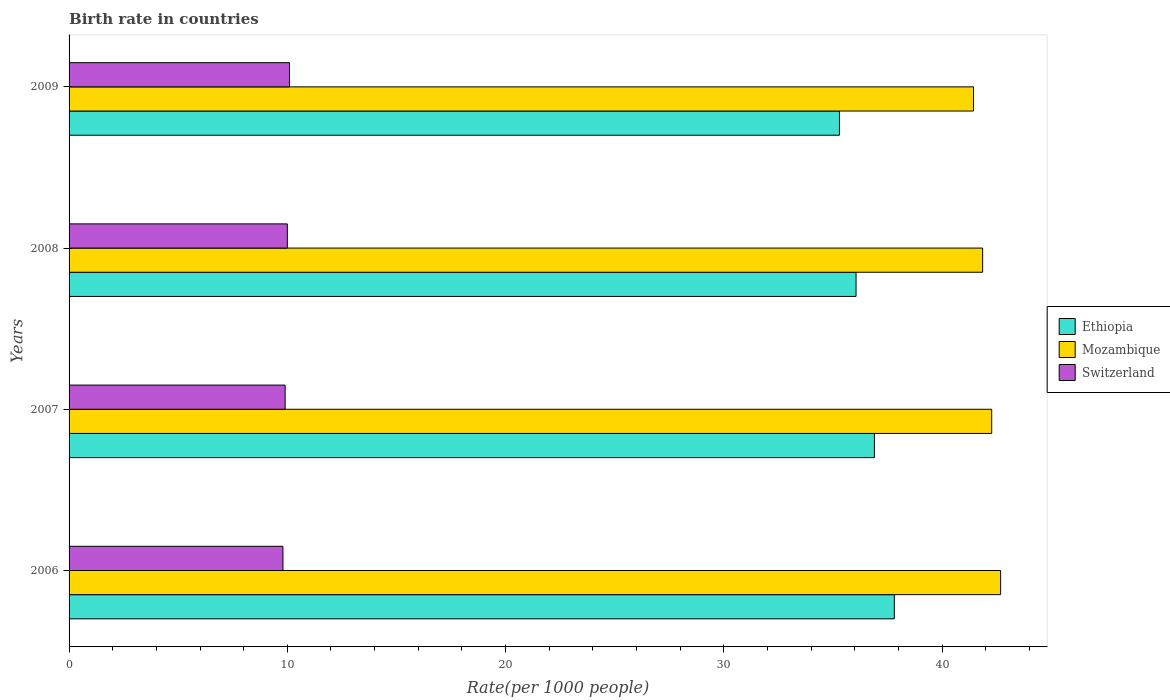How many groups of bars are there?
Your answer should be very brief. 4. Are the number of bars on each tick of the Y-axis equal?
Make the answer very short. Yes. How many bars are there on the 1st tick from the bottom?
Ensure brevity in your answer.  3. What is the birth rate in Ethiopia in 2007?
Offer a very short reply. 36.9. Across all years, what is the maximum birth rate in Mozambique?
Your answer should be compact. 42.69. Across all years, what is the minimum birth rate in Mozambique?
Offer a terse response. 41.44. What is the total birth rate in Switzerland in the graph?
Ensure brevity in your answer.  39.8. What is the difference between the birth rate in Ethiopia in 2008 and that in 2009?
Your answer should be compact. 0.76. What is the difference between the birth rate in Switzerland in 2006 and the birth rate in Ethiopia in 2008?
Give a very brief answer. -26.26. What is the average birth rate in Switzerland per year?
Make the answer very short. 9.95. In the year 2009, what is the difference between the birth rate in Ethiopia and birth rate in Mozambique?
Give a very brief answer. -6.14. What is the ratio of the birth rate in Ethiopia in 2006 to that in 2009?
Provide a short and direct response. 1.07. What is the difference between the highest and the second highest birth rate in Mozambique?
Provide a short and direct response. 0.41. What is the difference between the highest and the lowest birth rate in Ethiopia?
Make the answer very short. 2.51. In how many years, is the birth rate in Mozambique greater than the average birth rate in Mozambique taken over all years?
Ensure brevity in your answer.  2. Is the sum of the birth rate in Switzerland in 2007 and 2009 greater than the maximum birth rate in Mozambique across all years?
Make the answer very short. No. What does the 1st bar from the top in 2008 represents?
Keep it short and to the point. Switzerland. What does the 3rd bar from the bottom in 2006 represents?
Keep it short and to the point. Switzerland. Are the values on the major ticks of X-axis written in scientific E-notation?
Make the answer very short. No. Does the graph contain any zero values?
Give a very brief answer. No. Does the graph contain grids?
Your response must be concise. No. Where does the legend appear in the graph?
Provide a succinct answer. Center right. What is the title of the graph?
Keep it short and to the point. Birth rate in countries. Does "Tonga" appear as one of the legend labels in the graph?
Ensure brevity in your answer.  No. What is the label or title of the X-axis?
Your answer should be compact. Rate(per 1000 people). What is the label or title of the Y-axis?
Your answer should be compact. Years. What is the Rate(per 1000 people) of Ethiopia in 2006?
Keep it short and to the point. 37.81. What is the Rate(per 1000 people) in Mozambique in 2006?
Your answer should be compact. 42.69. What is the Rate(per 1000 people) in Switzerland in 2006?
Offer a very short reply. 9.8. What is the Rate(per 1000 people) of Ethiopia in 2007?
Provide a short and direct response. 36.9. What is the Rate(per 1000 people) of Mozambique in 2007?
Your response must be concise. 42.28. What is the Rate(per 1000 people) of Ethiopia in 2008?
Provide a short and direct response. 36.06. What is the Rate(per 1000 people) in Mozambique in 2008?
Make the answer very short. 41.86. What is the Rate(per 1000 people) of Ethiopia in 2009?
Your answer should be compact. 35.3. What is the Rate(per 1000 people) of Mozambique in 2009?
Offer a very short reply. 41.44. Across all years, what is the maximum Rate(per 1000 people) in Ethiopia?
Your response must be concise. 37.81. Across all years, what is the maximum Rate(per 1000 people) in Mozambique?
Offer a very short reply. 42.69. Across all years, what is the maximum Rate(per 1000 people) of Switzerland?
Keep it short and to the point. 10.1. Across all years, what is the minimum Rate(per 1000 people) of Ethiopia?
Give a very brief answer. 35.3. Across all years, what is the minimum Rate(per 1000 people) of Mozambique?
Ensure brevity in your answer.  41.44. Across all years, what is the minimum Rate(per 1000 people) in Switzerland?
Provide a succinct answer. 9.8. What is the total Rate(per 1000 people) of Ethiopia in the graph?
Provide a short and direct response. 146.08. What is the total Rate(per 1000 people) of Mozambique in the graph?
Offer a very short reply. 168.27. What is the total Rate(per 1000 people) of Switzerland in the graph?
Provide a short and direct response. 39.8. What is the difference between the Rate(per 1000 people) of Ethiopia in 2006 and that in 2007?
Give a very brief answer. 0.91. What is the difference between the Rate(per 1000 people) of Mozambique in 2006 and that in 2007?
Make the answer very short. 0.41. What is the difference between the Rate(per 1000 people) of Switzerland in 2006 and that in 2007?
Keep it short and to the point. -0.1. What is the difference between the Rate(per 1000 people) of Ethiopia in 2006 and that in 2008?
Keep it short and to the point. 1.75. What is the difference between the Rate(per 1000 people) of Mozambique in 2006 and that in 2008?
Offer a very short reply. 0.82. What is the difference between the Rate(per 1000 people) of Ethiopia in 2006 and that in 2009?
Your answer should be very brief. 2.51. What is the difference between the Rate(per 1000 people) of Mozambique in 2006 and that in 2009?
Your answer should be compact. 1.24. What is the difference between the Rate(per 1000 people) of Switzerland in 2006 and that in 2009?
Your answer should be compact. -0.3. What is the difference between the Rate(per 1000 people) of Ethiopia in 2007 and that in 2008?
Give a very brief answer. 0.84. What is the difference between the Rate(per 1000 people) in Mozambique in 2007 and that in 2008?
Make the answer very short. 0.41. What is the difference between the Rate(per 1000 people) of Ethiopia in 2007 and that in 2009?
Give a very brief answer. 1.6. What is the difference between the Rate(per 1000 people) in Mozambique in 2007 and that in 2009?
Give a very brief answer. 0.83. What is the difference between the Rate(per 1000 people) in Ethiopia in 2008 and that in 2009?
Your answer should be compact. 0.76. What is the difference between the Rate(per 1000 people) of Mozambique in 2008 and that in 2009?
Your answer should be compact. 0.42. What is the difference between the Rate(per 1000 people) of Switzerland in 2008 and that in 2009?
Offer a very short reply. -0.1. What is the difference between the Rate(per 1000 people) of Ethiopia in 2006 and the Rate(per 1000 people) of Mozambique in 2007?
Your answer should be compact. -4.46. What is the difference between the Rate(per 1000 people) of Ethiopia in 2006 and the Rate(per 1000 people) of Switzerland in 2007?
Keep it short and to the point. 27.91. What is the difference between the Rate(per 1000 people) of Mozambique in 2006 and the Rate(per 1000 people) of Switzerland in 2007?
Provide a short and direct response. 32.78. What is the difference between the Rate(per 1000 people) of Ethiopia in 2006 and the Rate(per 1000 people) of Mozambique in 2008?
Provide a short and direct response. -4.05. What is the difference between the Rate(per 1000 people) in Ethiopia in 2006 and the Rate(per 1000 people) in Switzerland in 2008?
Offer a terse response. 27.82. What is the difference between the Rate(per 1000 people) of Mozambique in 2006 and the Rate(per 1000 people) of Switzerland in 2008?
Provide a short and direct response. 32.69. What is the difference between the Rate(per 1000 people) in Ethiopia in 2006 and the Rate(per 1000 people) in Mozambique in 2009?
Provide a succinct answer. -3.63. What is the difference between the Rate(per 1000 people) of Ethiopia in 2006 and the Rate(per 1000 people) of Switzerland in 2009?
Your answer should be very brief. 27.71. What is the difference between the Rate(per 1000 people) of Mozambique in 2006 and the Rate(per 1000 people) of Switzerland in 2009?
Keep it short and to the point. 32.59. What is the difference between the Rate(per 1000 people) of Ethiopia in 2007 and the Rate(per 1000 people) of Mozambique in 2008?
Your answer should be compact. -4.96. What is the difference between the Rate(per 1000 people) of Ethiopia in 2007 and the Rate(per 1000 people) of Switzerland in 2008?
Give a very brief answer. 26.9. What is the difference between the Rate(per 1000 people) in Mozambique in 2007 and the Rate(per 1000 people) in Switzerland in 2008?
Provide a succinct answer. 32.28. What is the difference between the Rate(per 1000 people) in Ethiopia in 2007 and the Rate(per 1000 people) in Mozambique in 2009?
Your response must be concise. -4.54. What is the difference between the Rate(per 1000 people) of Ethiopia in 2007 and the Rate(per 1000 people) of Switzerland in 2009?
Give a very brief answer. 26.8. What is the difference between the Rate(per 1000 people) in Mozambique in 2007 and the Rate(per 1000 people) in Switzerland in 2009?
Give a very brief answer. 32.18. What is the difference between the Rate(per 1000 people) of Ethiopia in 2008 and the Rate(per 1000 people) of Mozambique in 2009?
Your answer should be very brief. -5.38. What is the difference between the Rate(per 1000 people) of Ethiopia in 2008 and the Rate(per 1000 people) of Switzerland in 2009?
Offer a terse response. 25.96. What is the difference between the Rate(per 1000 people) in Mozambique in 2008 and the Rate(per 1000 people) in Switzerland in 2009?
Provide a short and direct response. 31.76. What is the average Rate(per 1000 people) of Ethiopia per year?
Offer a very short reply. 36.52. What is the average Rate(per 1000 people) of Mozambique per year?
Your answer should be very brief. 42.07. What is the average Rate(per 1000 people) of Switzerland per year?
Your response must be concise. 9.95. In the year 2006, what is the difference between the Rate(per 1000 people) in Ethiopia and Rate(per 1000 people) in Mozambique?
Your answer should be very brief. -4.87. In the year 2006, what is the difference between the Rate(per 1000 people) in Ethiopia and Rate(per 1000 people) in Switzerland?
Provide a short and direct response. 28.02. In the year 2006, what is the difference between the Rate(per 1000 people) of Mozambique and Rate(per 1000 people) of Switzerland?
Offer a terse response. 32.88. In the year 2007, what is the difference between the Rate(per 1000 people) of Ethiopia and Rate(per 1000 people) of Mozambique?
Make the answer very short. -5.37. In the year 2007, what is the difference between the Rate(per 1000 people) of Ethiopia and Rate(per 1000 people) of Switzerland?
Keep it short and to the point. 27. In the year 2007, what is the difference between the Rate(per 1000 people) of Mozambique and Rate(per 1000 people) of Switzerland?
Give a very brief answer. 32.38. In the year 2008, what is the difference between the Rate(per 1000 people) of Ethiopia and Rate(per 1000 people) of Mozambique?
Your answer should be very brief. -5.8. In the year 2008, what is the difference between the Rate(per 1000 people) in Ethiopia and Rate(per 1000 people) in Switzerland?
Offer a terse response. 26.06. In the year 2008, what is the difference between the Rate(per 1000 people) in Mozambique and Rate(per 1000 people) in Switzerland?
Offer a very short reply. 31.86. In the year 2009, what is the difference between the Rate(per 1000 people) in Ethiopia and Rate(per 1000 people) in Mozambique?
Offer a very short reply. -6.14. In the year 2009, what is the difference between the Rate(per 1000 people) of Ethiopia and Rate(per 1000 people) of Switzerland?
Provide a short and direct response. 25.2. In the year 2009, what is the difference between the Rate(per 1000 people) of Mozambique and Rate(per 1000 people) of Switzerland?
Provide a short and direct response. 31.34. What is the ratio of the Rate(per 1000 people) in Ethiopia in 2006 to that in 2007?
Your answer should be compact. 1.02. What is the ratio of the Rate(per 1000 people) of Mozambique in 2006 to that in 2007?
Your response must be concise. 1.01. What is the ratio of the Rate(per 1000 people) in Ethiopia in 2006 to that in 2008?
Your answer should be compact. 1.05. What is the ratio of the Rate(per 1000 people) of Mozambique in 2006 to that in 2008?
Give a very brief answer. 1.02. What is the ratio of the Rate(per 1000 people) in Ethiopia in 2006 to that in 2009?
Give a very brief answer. 1.07. What is the ratio of the Rate(per 1000 people) of Mozambique in 2006 to that in 2009?
Give a very brief answer. 1.03. What is the ratio of the Rate(per 1000 people) of Switzerland in 2006 to that in 2009?
Provide a short and direct response. 0.97. What is the ratio of the Rate(per 1000 people) of Ethiopia in 2007 to that in 2008?
Keep it short and to the point. 1.02. What is the ratio of the Rate(per 1000 people) of Mozambique in 2007 to that in 2008?
Provide a short and direct response. 1.01. What is the ratio of the Rate(per 1000 people) of Switzerland in 2007 to that in 2008?
Offer a terse response. 0.99. What is the ratio of the Rate(per 1000 people) of Ethiopia in 2007 to that in 2009?
Your answer should be compact. 1.05. What is the ratio of the Rate(per 1000 people) in Mozambique in 2007 to that in 2009?
Give a very brief answer. 1.02. What is the ratio of the Rate(per 1000 people) of Switzerland in 2007 to that in 2009?
Your answer should be compact. 0.98. What is the ratio of the Rate(per 1000 people) in Ethiopia in 2008 to that in 2009?
Provide a short and direct response. 1.02. What is the ratio of the Rate(per 1000 people) of Mozambique in 2008 to that in 2009?
Give a very brief answer. 1.01. What is the ratio of the Rate(per 1000 people) of Switzerland in 2008 to that in 2009?
Ensure brevity in your answer.  0.99. What is the difference between the highest and the second highest Rate(per 1000 people) of Ethiopia?
Your answer should be compact. 0.91. What is the difference between the highest and the second highest Rate(per 1000 people) of Mozambique?
Ensure brevity in your answer.  0.41. What is the difference between the highest and the lowest Rate(per 1000 people) of Ethiopia?
Offer a terse response. 2.51. What is the difference between the highest and the lowest Rate(per 1000 people) in Mozambique?
Provide a succinct answer. 1.24. 